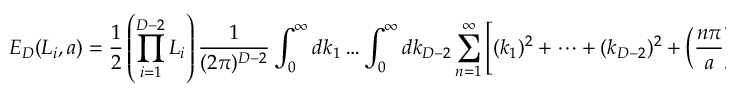Convert formula to latex. <formula><loc_0><loc_0><loc_500><loc_500>E _ { D } ( L _ { i } , a ) = \frac { 1 } { 2 } \left ( \prod _ { i = 1 } ^ { D - 2 } L _ { i } \right ) \frac { 1 } { ( 2 \pi ) ^ { D - 2 } } \int _ { 0 } ^ { \infty } d k _ { 1 } \dots \int _ { 0 } ^ { \infty } d k _ { D - 2 } \sum _ { n = 1 } ^ { \infty } \left [ ( k _ { 1 } ) ^ { 2 } + \dots + ( k _ { D - 2 } ) ^ { 2 } + \left ( \frac { n \pi } { a } \right ) ^ { 2 } \right ] ^ { \frac { 1 } { 2 } } .</formula> 